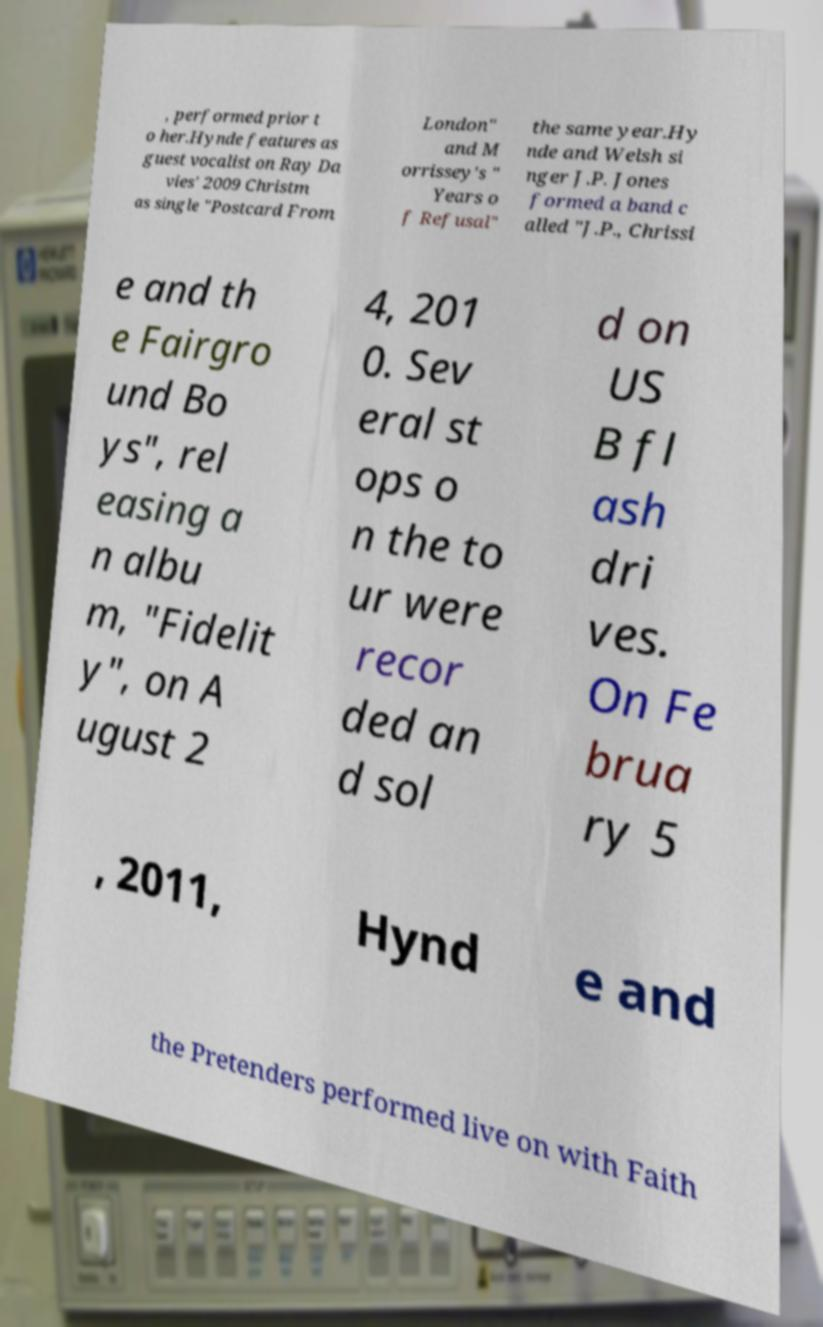Can you read and provide the text displayed in the image?This photo seems to have some interesting text. Can you extract and type it out for me? , performed prior t o her.Hynde features as guest vocalist on Ray Da vies' 2009 Christm as single "Postcard From London" and M orrissey's " Years o f Refusal" the same year.Hy nde and Welsh si nger J.P. Jones formed a band c alled "J.P., Chrissi e and th e Fairgro und Bo ys", rel easing a n albu m, "Fidelit y", on A ugust 2 4, 201 0. Sev eral st ops o n the to ur were recor ded an d sol d on US B fl ash dri ves. On Fe brua ry 5 , 2011, Hynd e and the Pretenders performed live on with Faith 